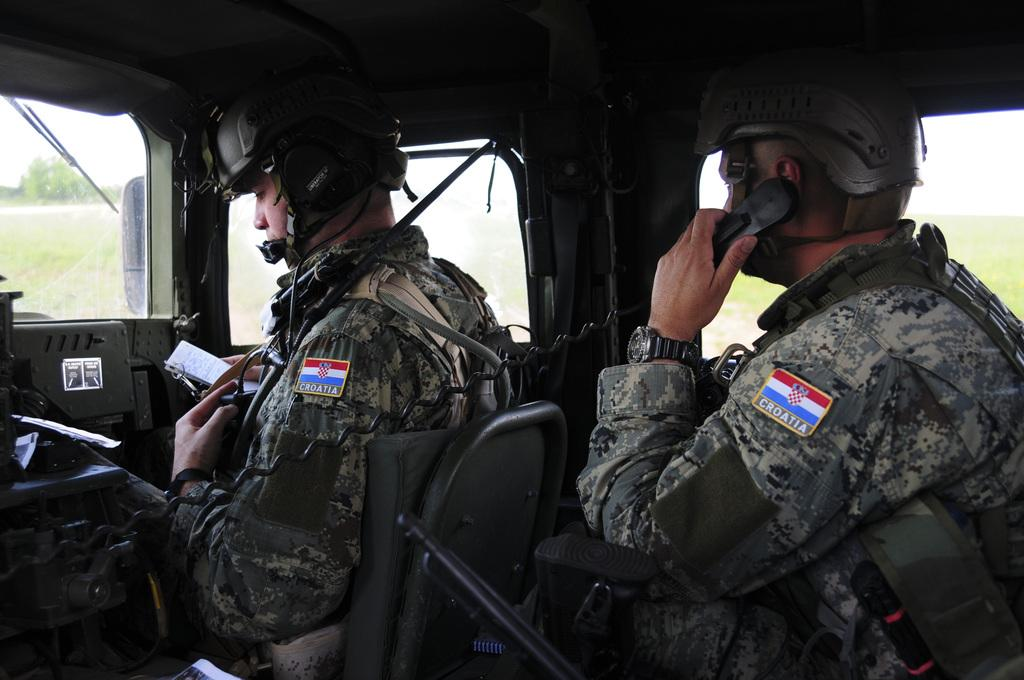What is happening inside the vehicle in the image? There are persons sitting inside the vehicle. What can be seen outside the vehicle through the windows? Trees are visible outside the windows of the vehicle. What type of ice can be seen melting on the cabbage in the image? There is no ice or cabbage present in the image; it only features persons sitting inside a vehicle with trees visible outside the windows. 